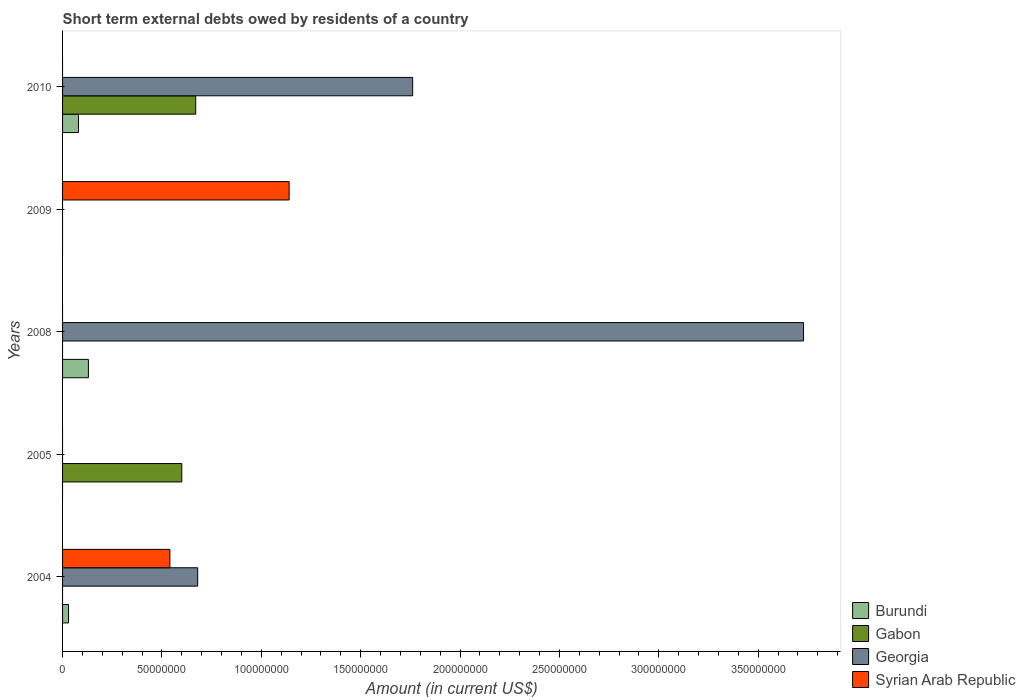How many bars are there on the 4th tick from the top?
Offer a terse response. 1. How many bars are there on the 2nd tick from the bottom?
Provide a succinct answer. 1. What is the label of the 1st group of bars from the top?
Make the answer very short. 2010. Across all years, what is the maximum amount of short-term external debts owed by residents in Burundi?
Provide a short and direct response. 1.30e+07. What is the total amount of short-term external debts owed by residents in Gabon in the graph?
Offer a terse response. 1.27e+08. What is the difference between the amount of short-term external debts owed by residents in Georgia in 2004 and that in 2010?
Ensure brevity in your answer.  -1.08e+08. What is the difference between the amount of short-term external debts owed by residents in Gabon in 2004 and the amount of short-term external debts owed by residents in Georgia in 2010?
Offer a terse response. -1.76e+08. What is the average amount of short-term external debts owed by residents in Georgia per year?
Ensure brevity in your answer.  1.23e+08. In the year 2004, what is the difference between the amount of short-term external debts owed by residents in Burundi and amount of short-term external debts owed by residents in Georgia?
Give a very brief answer. -6.50e+07. What is the ratio of the amount of short-term external debts owed by residents in Georgia in 2004 to that in 2010?
Offer a very short reply. 0.39. What is the difference between the highest and the lowest amount of short-term external debts owed by residents in Georgia?
Your response must be concise. 3.73e+08. In how many years, is the amount of short-term external debts owed by residents in Gabon greater than the average amount of short-term external debts owed by residents in Gabon taken over all years?
Give a very brief answer. 2. Is it the case that in every year, the sum of the amount of short-term external debts owed by residents in Syrian Arab Republic and amount of short-term external debts owed by residents in Georgia is greater than the sum of amount of short-term external debts owed by residents in Gabon and amount of short-term external debts owed by residents in Burundi?
Offer a terse response. No. Is it the case that in every year, the sum of the amount of short-term external debts owed by residents in Syrian Arab Republic and amount of short-term external debts owed by residents in Georgia is greater than the amount of short-term external debts owed by residents in Burundi?
Give a very brief answer. No. How many years are there in the graph?
Offer a terse response. 5. What is the difference between two consecutive major ticks on the X-axis?
Give a very brief answer. 5.00e+07. Does the graph contain grids?
Provide a succinct answer. No. Where does the legend appear in the graph?
Your answer should be very brief. Bottom right. How many legend labels are there?
Provide a succinct answer. 4. What is the title of the graph?
Provide a short and direct response. Short term external debts owed by residents of a country. What is the label or title of the X-axis?
Make the answer very short. Amount (in current US$). What is the Amount (in current US$) of Burundi in 2004?
Provide a succinct answer. 3.00e+06. What is the Amount (in current US$) of Georgia in 2004?
Provide a succinct answer. 6.80e+07. What is the Amount (in current US$) of Syrian Arab Republic in 2004?
Keep it short and to the point. 5.40e+07. What is the Amount (in current US$) in Gabon in 2005?
Provide a succinct answer. 6.00e+07. What is the Amount (in current US$) of Burundi in 2008?
Offer a very short reply. 1.30e+07. What is the Amount (in current US$) of Gabon in 2008?
Your response must be concise. 0. What is the Amount (in current US$) of Georgia in 2008?
Your response must be concise. 3.73e+08. What is the Amount (in current US$) of Syrian Arab Republic in 2008?
Make the answer very short. 0. What is the Amount (in current US$) in Burundi in 2009?
Your answer should be compact. 0. What is the Amount (in current US$) in Georgia in 2009?
Your response must be concise. 0. What is the Amount (in current US$) of Syrian Arab Republic in 2009?
Your answer should be very brief. 1.14e+08. What is the Amount (in current US$) of Burundi in 2010?
Keep it short and to the point. 8.00e+06. What is the Amount (in current US$) of Gabon in 2010?
Make the answer very short. 6.70e+07. What is the Amount (in current US$) in Georgia in 2010?
Provide a short and direct response. 1.76e+08. Across all years, what is the maximum Amount (in current US$) in Burundi?
Make the answer very short. 1.30e+07. Across all years, what is the maximum Amount (in current US$) of Gabon?
Make the answer very short. 6.70e+07. Across all years, what is the maximum Amount (in current US$) in Georgia?
Make the answer very short. 3.73e+08. Across all years, what is the maximum Amount (in current US$) in Syrian Arab Republic?
Make the answer very short. 1.14e+08. Across all years, what is the minimum Amount (in current US$) of Georgia?
Give a very brief answer. 0. Across all years, what is the minimum Amount (in current US$) of Syrian Arab Republic?
Keep it short and to the point. 0. What is the total Amount (in current US$) in Burundi in the graph?
Provide a short and direct response. 2.40e+07. What is the total Amount (in current US$) in Gabon in the graph?
Your answer should be very brief. 1.27e+08. What is the total Amount (in current US$) in Georgia in the graph?
Offer a terse response. 6.17e+08. What is the total Amount (in current US$) of Syrian Arab Republic in the graph?
Offer a terse response. 1.68e+08. What is the difference between the Amount (in current US$) of Burundi in 2004 and that in 2008?
Your answer should be compact. -1.00e+07. What is the difference between the Amount (in current US$) in Georgia in 2004 and that in 2008?
Your answer should be very brief. -3.05e+08. What is the difference between the Amount (in current US$) in Syrian Arab Republic in 2004 and that in 2009?
Your response must be concise. -6.00e+07. What is the difference between the Amount (in current US$) of Burundi in 2004 and that in 2010?
Make the answer very short. -5.00e+06. What is the difference between the Amount (in current US$) in Georgia in 2004 and that in 2010?
Keep it short and to the point. -1.08e+08. What is the difference between the Amount (in current US$) of Gabon in 2005 and that in 2010?
Give a very brief answer. -7.00e+06. What is the difference between the Amount (in current US$) of Georgia in 2008 and that in 2010?
Provide a succinct answer. 1.97e+08. What is the difference between the Amount (in current US$) in Burundi in 2004 and the Amount (in current US$) in Gabon in 2005?
Ensure brevity in your answer.  -5.70e+07. What is the difference between the Amount (in current US$) in Burundi in 2004 and the Amount (in current US$) in Georgia in 2008?
Provide a succinct answer. -3.70e+08. What is the difference between the Amount (in current US$) of Burundi in 2004 and the Amount (in current US$) of Syrian Arab Republic in 2009?
Provide a short and direct response. -1.11e+08. What is the difference between the Amount (in current US$) of Georgia in 2004 and the Amount (in current US$) of Syrian Arab Republic in 2009?
Ensure brevity in your answer.  -4.60e+07. What is the difference between the Amount (in current US$) in Burundi in 2004 and the Amount (in current US$) in Gabon in 2010?
Make the answer very short. -6.40e+07. What is the difference between the Amount (in current US$) of Burundi in 2004 and the Amount (in current US$) of Georgia in 2010?
Your answer should be compact. -1.73e+08. What is the difference between the Amount (in current US$) of Gabon in 2005 and the Amount (in current US$) of Georgia in 2008?
Provide a succinct answer. -3.13e+08. What is the difference between the Amount (in current US$) of Gabon in 2005 and the Amount (in current US$) of Syrian Arab Republic in 2009?
Offer a terse response. -5.40e+07. What is the difference between the Amount (in current US$) in Gabon in 2005 and the Amount (in current US$) in Georgia in 2010?
Offer a terse response. -1.16e+08. What is the difference between the Amount (in current US$) of Burundi in 2008 and the Amount (in current US$) of Syrian Arab Republic in 2009?
Offer a very short reply. -1.01e+08. What is the difference between the Amount (in current US$) in Georgia in 2008 and the Amount (in current US$) in Syrian Arab Republic in 2009?
Keep it short and to the point. 2.59e+08. What is the difference between the Amount (in current US$) of Burundi in 2008 and the Amount (in current US$) of Gabon in 2010?
Keep it short and to the point. -5.40e+07. What is the difference between the Amount (in current US$) in Burundi in 2008 and the Amount (in current US$) in Georgia in 2010?
Offer a very short reply. -1.63e+08. What is the average Amount (in current US$) in Burundi per year?
Ensure brevity in your answer.  4.80e+06. What is the average Amount (in current US$) of Gabon per year?
Give a very brief answer. 2.54e+07. What is the average Amount (in current US$) of Georgia per year?
Keep it short and to the point. 1.23e+08. What is the average Amount (in current US$) in Syrian Arab Republic per year?
Keep it short and to the point. 3.36e+07. In the year 2004, what is the difference between the Amount (in current US$) of Burundi and Amount (in current US$) of Georgia?
Your answer should be very brief. -6.50e+07. In the year 2004, what is the difference between the Amount (in current US$) of Burundi and Amount (in current US$) of Syrian Arab Republic?
Your response must be concise. -5.10e+07. In the year 2004, what is the difference between the Amount (in current US$) of Georgia and Amount (in current US$) of Syrian Arab Republic?
Provide a short and direct response. 1.40e+07. In the year 2008, what is the difference between the Amount (in current US$) of Burundi and Amount (in current US$) of Georgia?
Keep it short and to the point. -3.60e+08. In the year 2010, what is the difference between the Amount (in current US$) in Burundi and Amount (in current US$) in Gabon?
Offer a terse response. -5.90e+07. In the year 2010, what is the difference between the Amount (in current US$) of Burundi and Amount (in current US$) of Georgia?
Provide a short and direct response. -1.68e+08. In the year 2010, what is the difference between the Amount (in current US$) in Gabon and Amount (in current US$) in Georgia?
Your answer should be very brief. -1.09e+08. What is the ratio of the Amount (in current US$) of Burundi in 2004 to that in 2008?
Your answer should be very brief. 0.23. What is the ratio of the Amount (in current US$) of Georgia in 2004 to that in 2008?
Your response must be concise. 0.18. What is the ratio of the Amount (in current US$) in Syrian Arab Republic in 2004 to that in 2009?
Keep it short and to the point. 0.47. What is the ratio of the Amount (in current US$) in Burundi in 2004 to that in 2010?
Your answer should be very brief. 0.38. What is the ratio of the Amount (in current US$) in Georgia in 2004 to that in 2010?
Your answer should be compact. 0.39. What is the ratio of the Amount (in current US$) of Gabon in 2005 to that in 2010?
Your answer should be compact. 0.9. What is the ratio of the Amount (in current US$) of Burundi in 2008 to that in 2010?
Give a very brief answer. 1.62. What is the ratio of the Amount (in current US$) in Georgia in 2008 to that in 2010?
Your response must be concise. 2.12. What is the difference between the highest and the second highest Amount (in current US$) in Burundi?
Offer a very short reply. 5.00e+06. What is the difference between the highest and the second highest Amount (in current US$) of Georgia?
Offer a terse response. 1.97e+08. What is the difference between the highest and the lowest Amount (in current US$) of Burundi?
Provide a succinct answer. 1.30e+07. What is the difference between the highest and the lowest Amount (in current US$) in Gabon?
Offer a terse response. 6.70e+07. What is the difference between the highest and the lowest Amount (in current US$) in Georgia?
Keep it short and to the point. 3.73e+08. What is the difference between the highest and the lowest Amount (in current US$) in Syrian Arab Republic?
Offer a very short reply. 1.14e+08. 